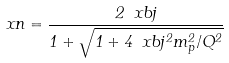<formula> <loc_0><loc_0><loc_500><loc_500>\ x n = \frac { 2 \ x b j } { 1 + \sqrt { 1 + 4 \ x b j ^ { 2 } m _ { p } ^ { 2 } / Q ^ { 2 } } }</formula> 